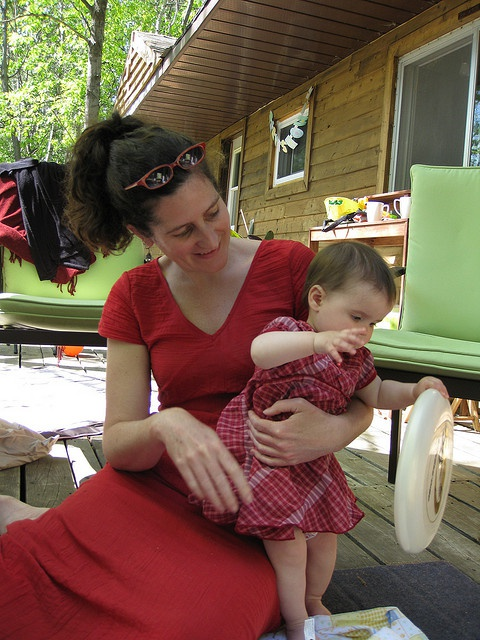Describe the objects in this image and their specific colors. I can see people in lightgreen, maroon, brown, black, and gray tones, people in lightgreen, maroon, brown, and black tones, chair in lightgreen and black tones, frisbee in lightgreen, darkgray, beige, and tan tones, and cup in lightgreen, white, tan, and gold tones in this image. 